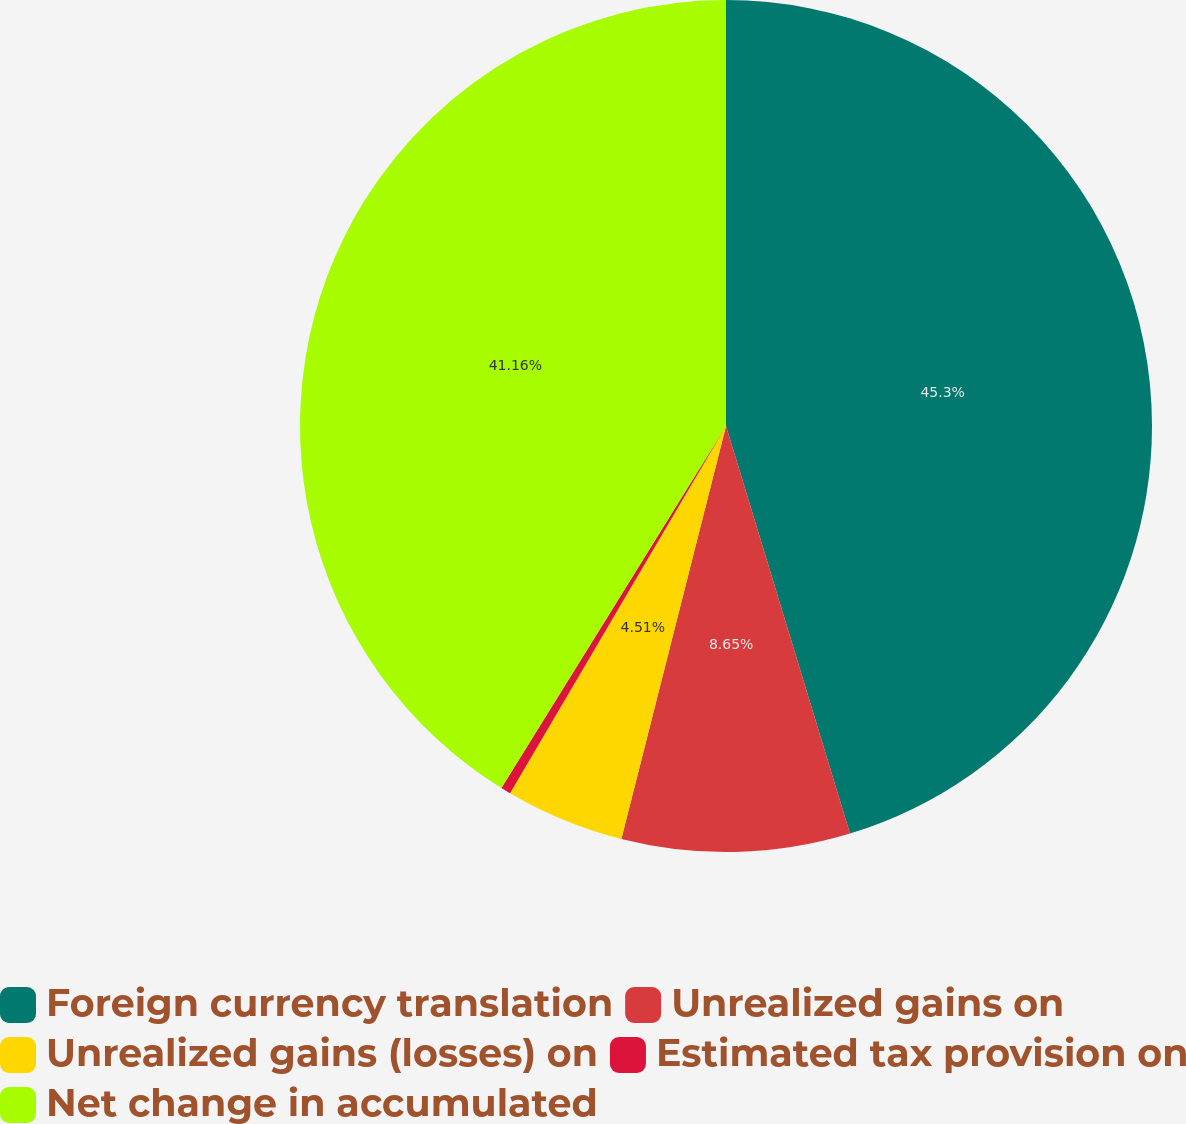Convert chart to OTSL. <chart><loc_0><loc_0><loc_500><loc_500><pie_chart><fcel>Foreign currency translation<fcel>Unrealized gains on<fcel>Unrealized gains (losses) on<fcel>Estimated tax provision on<fcel>Net change in accumulated<nl><fcel>45.3%<fcel>8.65%<fcel>4.51%<fcel>0.38%<fcel>41.16%<nl></chart> 